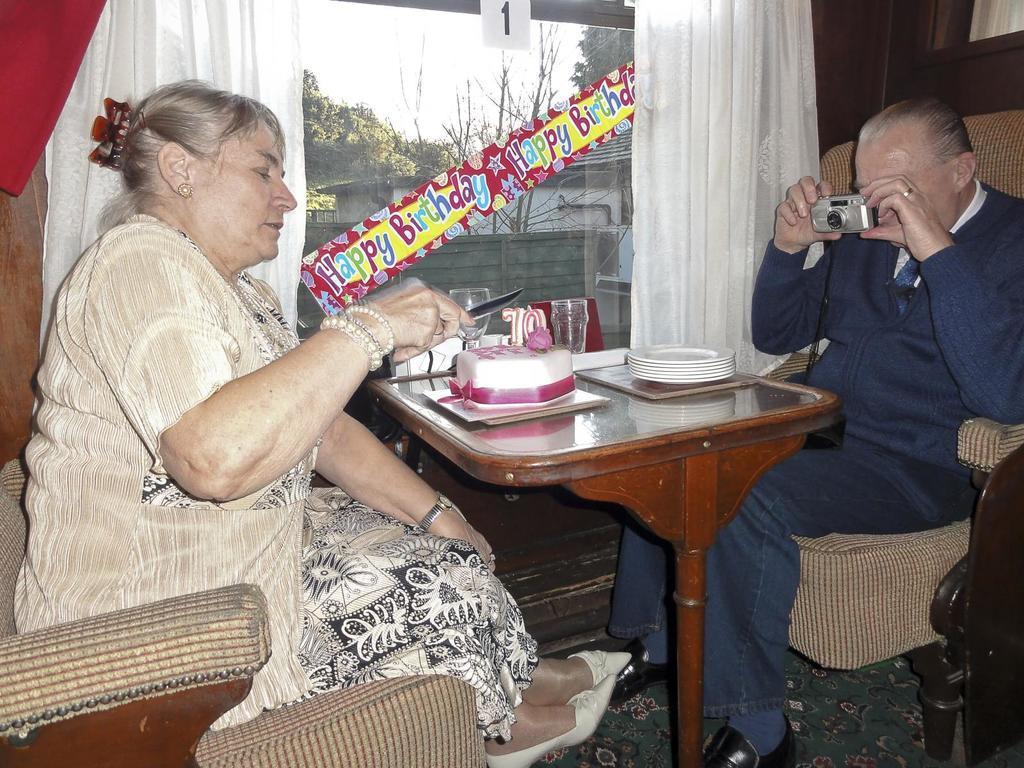Could you give a brief overview of what you see in this image? In this image we have a woman and a man who are sitting on the chair in front of the table. On the table we have few glasses, few plates and a cake. On the left side woman is cutting a cake with a knife and the person on the right side is holding a camera and taking a picture. Beside this man we have a white curtain and a glass window. 